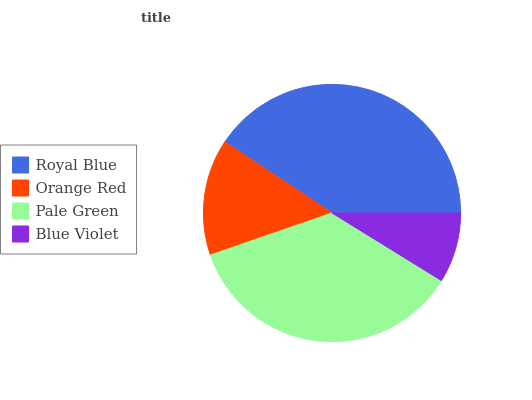Is Blue Violet the minimum?
Answer yes or no. Yes. Is Royal Blue the maximum?
Answer yes or no. Yes. Is Orange Red the minimum?
Answer yes or no. No. Is Orange Red the maximum?
Answer yes or no. No. Is Royal Blue greater than Orange Red?
Answer yes or no. Yes. Is Orange Red less than Royal Blue?
Answer yes or no. Yes. Is Orange Red greater than Royal Blue?
Answer yes or no. No. Is Royal Blue less than Orange Red?
Answer yes or no. No. Is Pale Green the high median?
Answer yes or no. Yes. Is Orange Red the low median?
Answer yes or no. Yes. Is Royal Blue the high median?
Answer yes or no. No. Is Pale Green the low median?
Answer yes or no. No. 